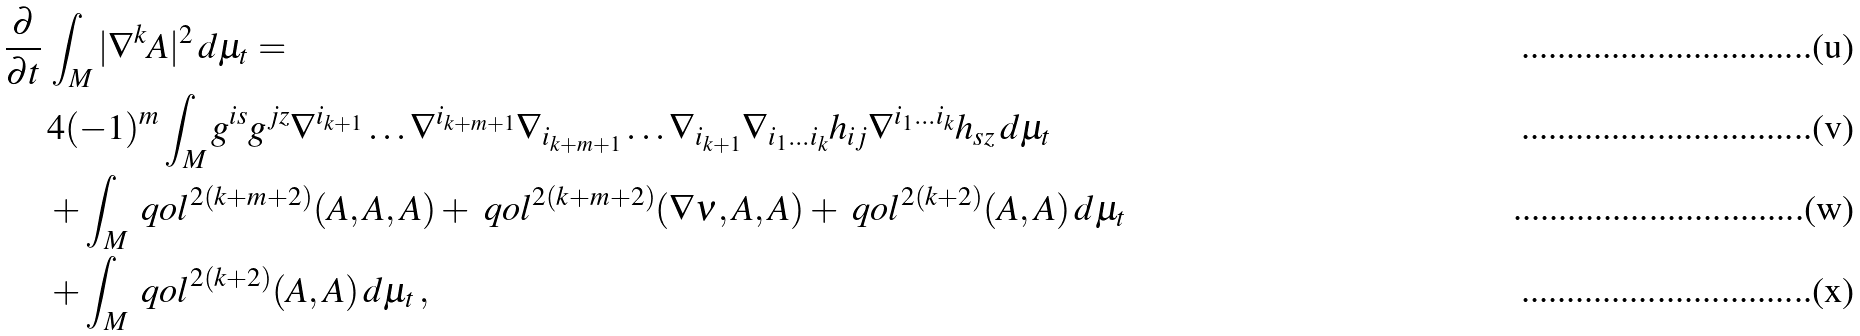<formula> <loc_0><loc_0><loc_500><loc_500>\frac { \partial } { \partial t } & \, \int _ { M } | \nabla ^ { k } \AA A | ^ { 2 } \, d \mu _ { t } = \\ \, & \, 4 ( - 1 ) ^ { m } \int _ { M } g ^ { i s } g ^ { j z } \nabla ^ { i _ { k + 1 } } \dots \nabla ^ { i _ { k + m + 1 } } \nabla _ { i _ { k + m + 1 } } \dots \nabla _ { i _ { k + 1 } } \nabla _ { i _ { 1 } \dots i _ { k } } h _ { i j } \nabla ^ { i _ { 1 } \dots i _ { k } } h _ { s z } \, d \mu _ { t } \\ \, & \, + \int _ { M } \ q o l ^ { 2 ( k + m + 2 ) } ( \AA A , \AA A , \AA A ) + \ q o l ^ { 2 ( k + m + 2 ) } ( \nabla \nu , \AA A , \AA A ) + \ q o l ^ { 2 ( k + 2 ) } ( \AA A , \AA A ) \, d \mu _ { t } \\ \, & \, + \int _ { M } \ q o l ^ { 2 ( k + 2 ) } ( \AA A , \AA A ) \, d \mu _ { t } \, ,</formula> 